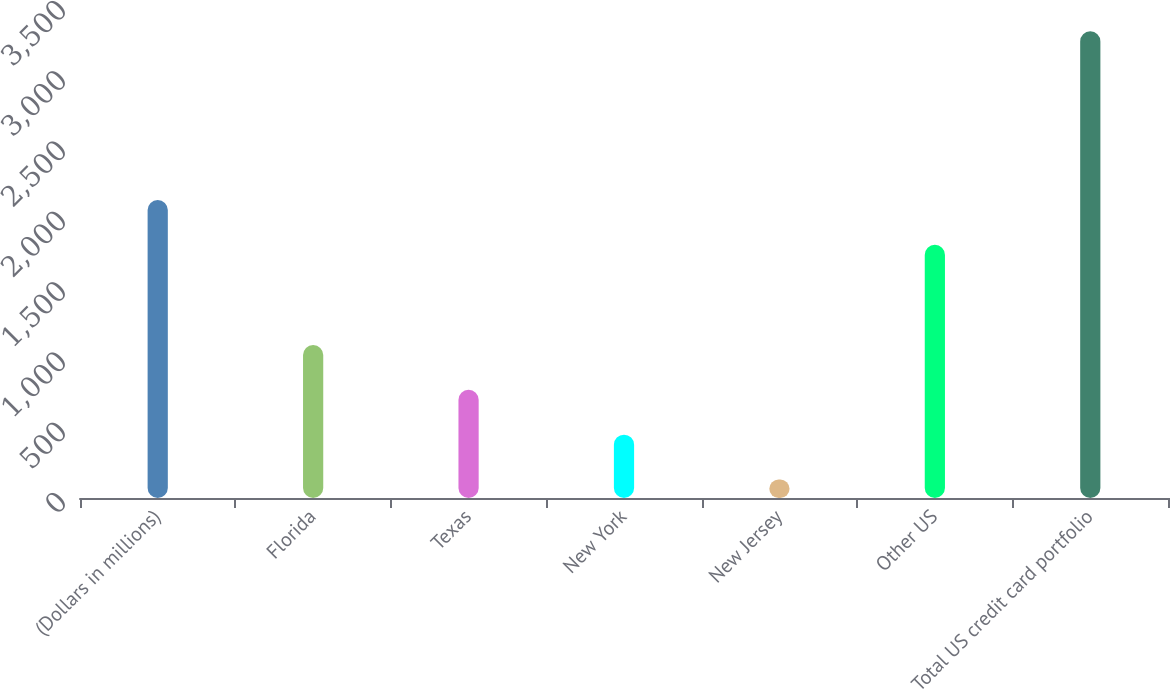<chart> <loc_0><loc_0><loc_500><loc_500><bar_chart><fcel>(Dollars in millions)<fcel>Florida<fcel>Texas<fcel>New York<fcel>New Jersey<fcel>Other US<fcel>Total US credit card portfolio<nl><fcel>2119.8<fcel>1088.4<fcel>769.6<fcel>450.8<fcel>132<fcel>1801<fcel>3320<nl></chart> 